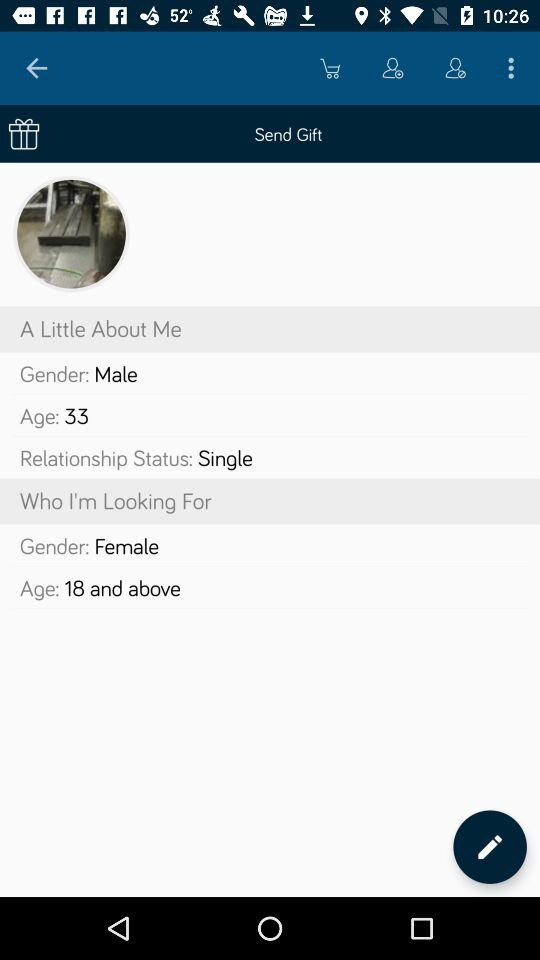What is the relationship status? The relationship status is single. 